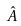<formula> <loc_0><loc_0><loc_500><loc_500>\hat { A }</formula> 